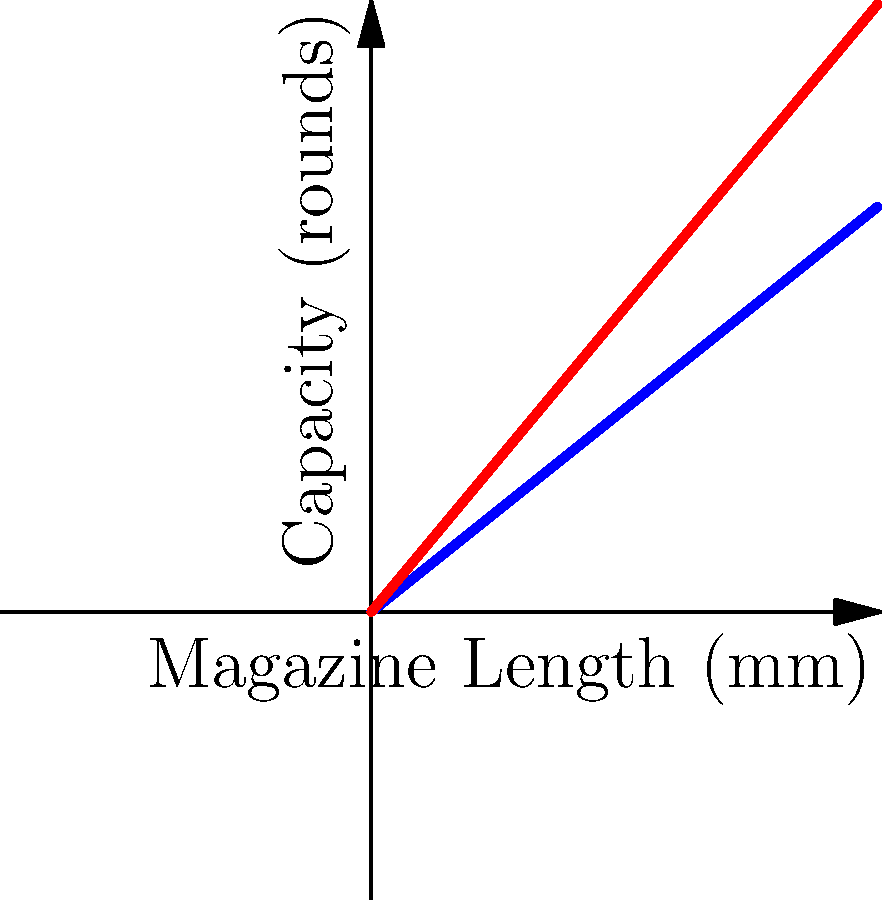As a gun store owner, you're explaining magazine capacities to a police officer. The graph shows the relationship between magazine length and capacity for 9mm and .45 ACP ammunition. Point A represents a 50mm long 9mm magazine, while point B represents a 75mm long .45 ACP magazine. What is the difference in capacity between these two magazines? To solve this problem, we need to follow these steps:

1) First, let's determine the capacity of the 9mm magazine (Point A):
   - The x-coordinate (length) is 50mm
   - Using the blue line (9mm), we can see that the y-coordinate (capacity) is 40 rounds

2) Next, let's determine the capacity of the .45 ACP magazine (Point B):
   - The x-coordinate (length) is 75mm
   - Using the red line (.45 ACP), we can see that the y-coordinate (capacity) is 90 rounds

3) To find the difference in capacity, we subtract:
   $90 - 40 = 50$

Therefore, the difference in capacity between the two magazines is 50 rounds.

This demonstrates how larger caliber ammunition (.45 ACP) can sometimes allow for higher capacity in longer magazines, despite being physically larger, due to differences in cartridge shape and magazine design.
Answer: 50 rounds 